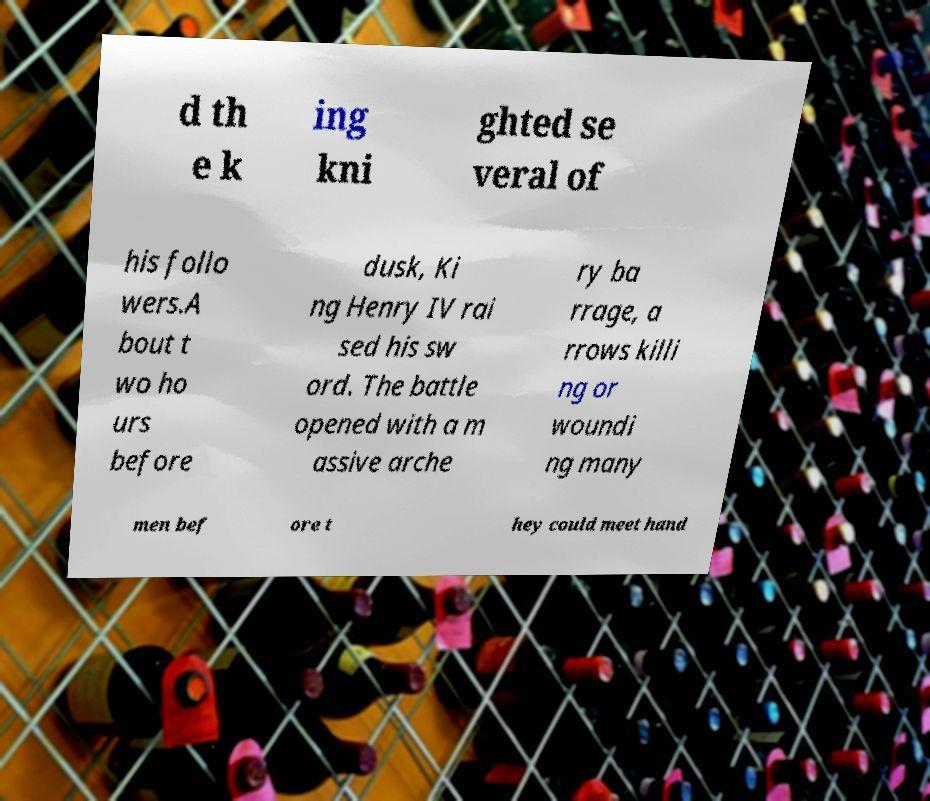Please identify and transcribe the text found in this image. d th e k ing kni ghted se veral of his follo wers.A bout t wo ho urs before dusk, Ki ng Henry IV rai sed his sw ord. The battle opened with a m assive arche ry ba rrage, a rrows killi ng or woundi ng many men bef ore t hey could meet hand 